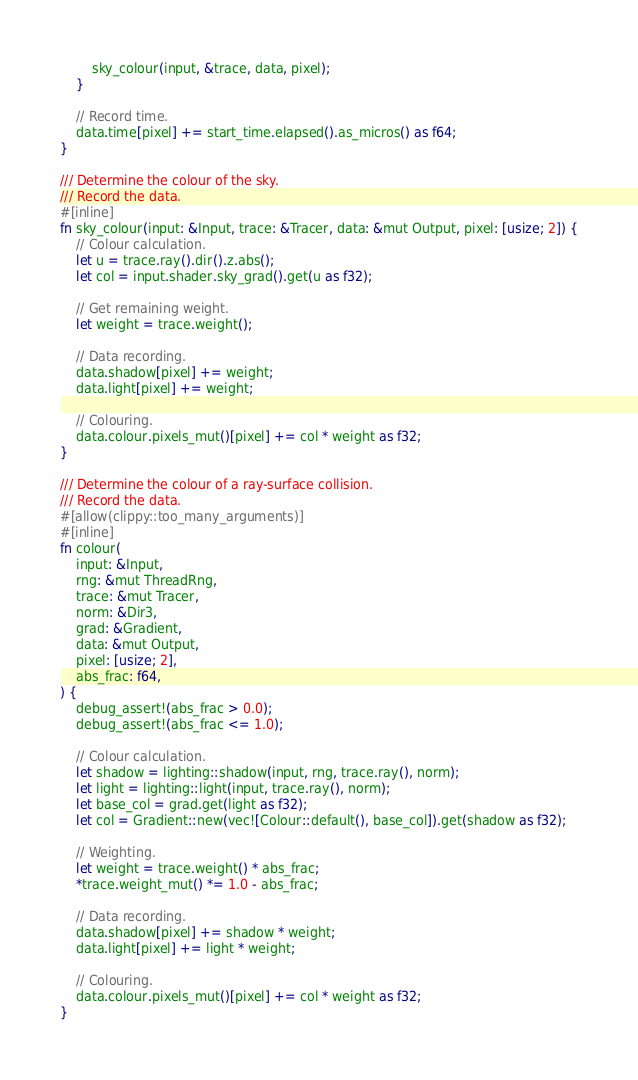Convert code to text. <code><loc_0><loc_0><loc_500><loc_500><_Rust_>        sky_colour(input, &trace, data, pixel);
    }

    // Record time.
    data.time[pixel] += start_time.elapsed().as_micros() as f64;
}

/// Determine the colour of the sky.
/// Record the data.
#[inline]
fn sky_colour(input: &Input, trace: &Tracer, data: &mut Output, pixel: [usize; 2]) {
    // Colour calculation.
    let u = trace.ray().dir().z.abs();
    let col = input.shader.sky_grad().get(u as f32);

    // Get remaining weight.
    let weight = trace.weight();

    // Data recording.
    data.shadow[pixel] += weight;
    data.light[pixel] += weight;

    // Colouring.
    data.colour.pixels_mut()[pixel] += col * weight as f32;
}

/// Determine the colour of a ray-surface collision.
/// Record the data.
#[allow(clippy::too_many_arguments)]
#[inline]
fn colour(
    input: &Input,
    rng: &mut ThreadRng,
    trace: &mut Tracer,
    norm: &Dir3,
    grad: &Gradient,
    data: &mut Output,
    pixel: [usize; 2],
    abs_frac: f64,
) {
    debug_assert!(abs_frac > 0.0);
    debug_assert!(abs_frac <= 1.0);

    // Colour calculation.
    let shadow = lighting::shadow(input, rng, trace.ray(), norm);
    let light = lighting::light(input, trace.ray(), norm);
    let base_col = grad.get(light as f32);
    let col = Gradient::new(vec![Colour::default(), base_col]).get(shadow as f32);

    // Weighting.
    let weight = trace.weight() * abs_frac;
    *trace.weight_mut() *= 1.0 - abs_frac;

    // Data recording.
    data.shadow[pixel] += shadow * weight;
    data.light[pixel] += light * weight;

    // Colouring.
    data.colour.pixels_mut()[pixel] += col * weight as f32;
}
</code> 